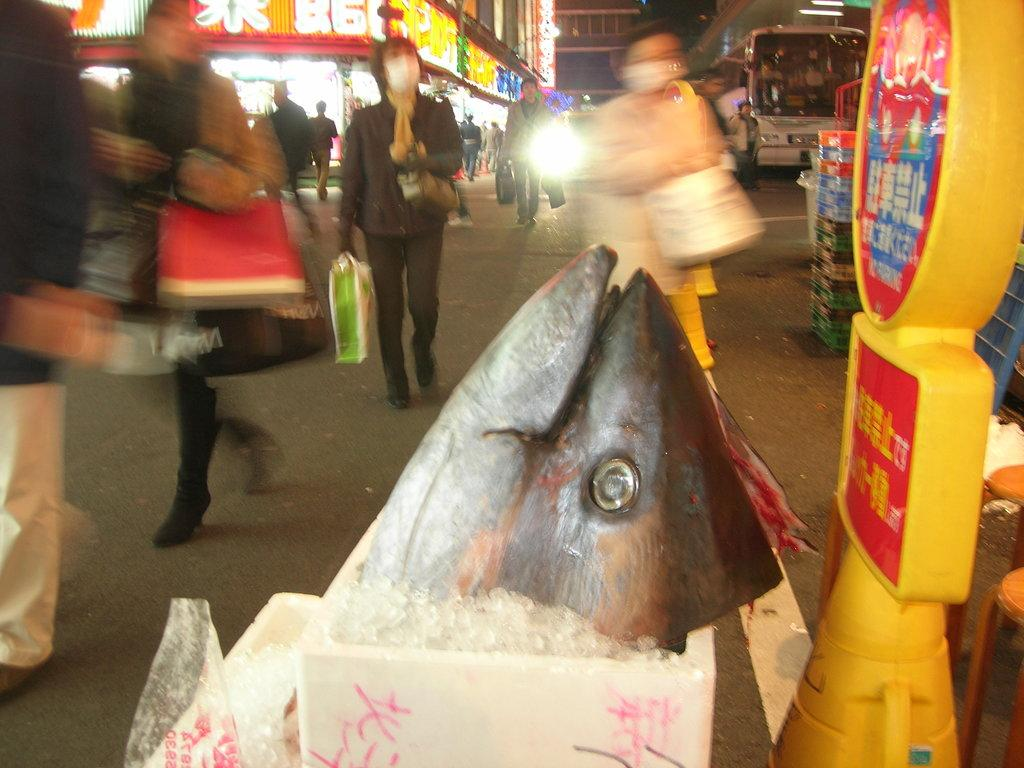What is the main subject in the center of the image? There is a fish in the center of the image. What can be seen on the right side of the image? There is a sign board on the right side of the image. What is visible in the background of the image? There are persons, a bus, a road, and buildings visible in the background of the image. How many fingers can be seen on the fish in the image? Fish do not have fingers, so there are no fingers visible on the fish in the image. 